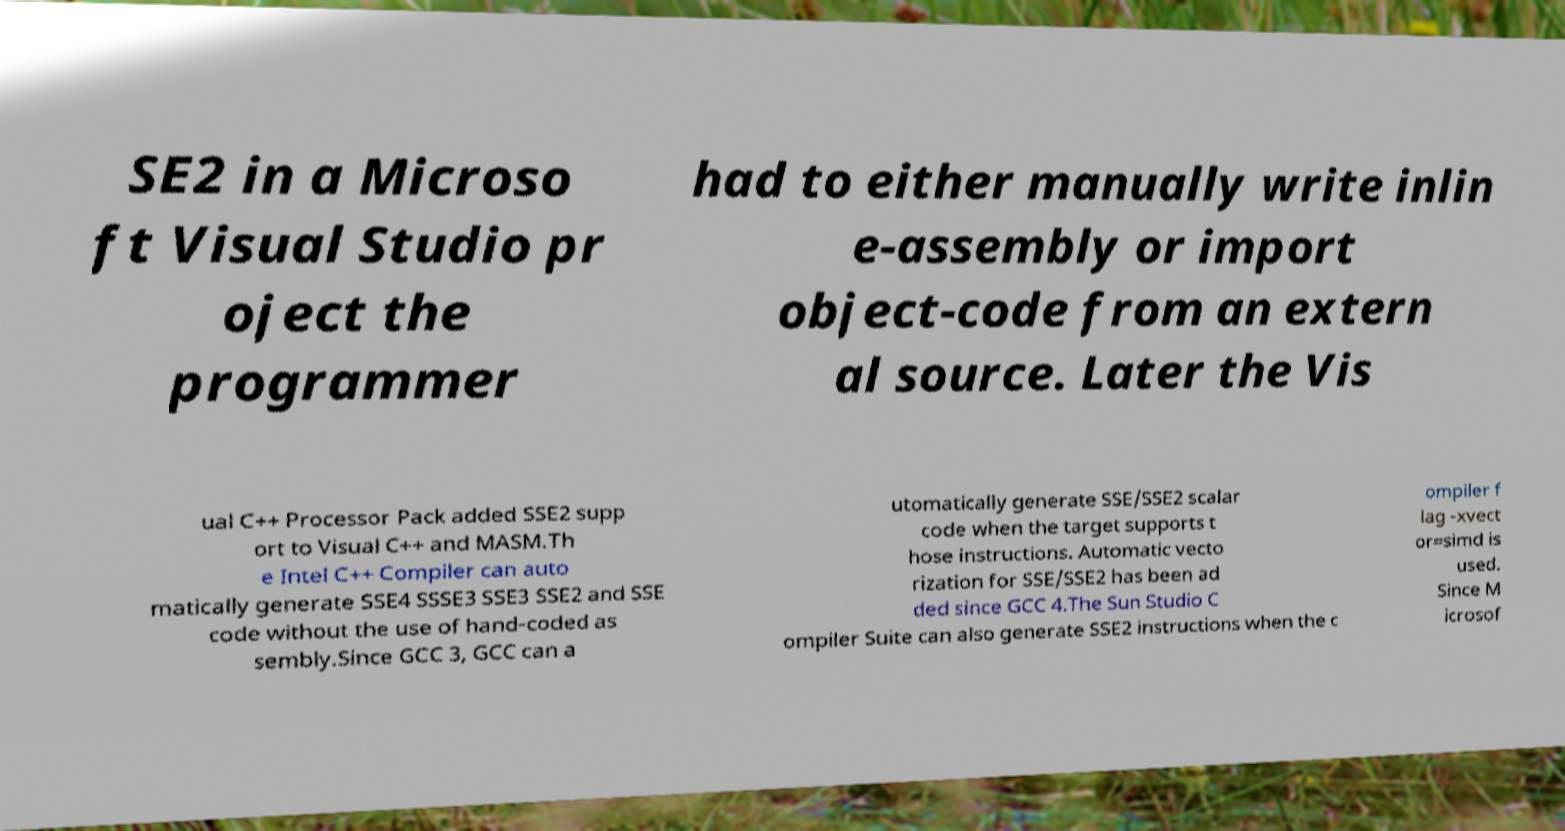Could you extract and type out the text from this image? SE2 in a Microso ft Visual Studio pr oject the programmer had to either manually write inlin e-assembly or import object-code from an extern al source. Later the Vis ual C++ Processor Pack added SSE2 supp ort to Visual C++ and MASM.Th e Intel C++ Compiler can auto matically generate SSE4 SSSE3 SSE3 SSE2 and SSE code without the use of hand-coded as sembly.Since GCC 3, GCC can a utomatically generate SSE/SSE2 scalar code when the target supports t hose instructions. Automatic vecto rization for SSE/SSE2 has been ad ded since GCC 4.The Sun Studio C ompiler Suite can also generate SSE2 instructions when the c ompiler f lag -xvect or=simd is used. Since M icrosof 